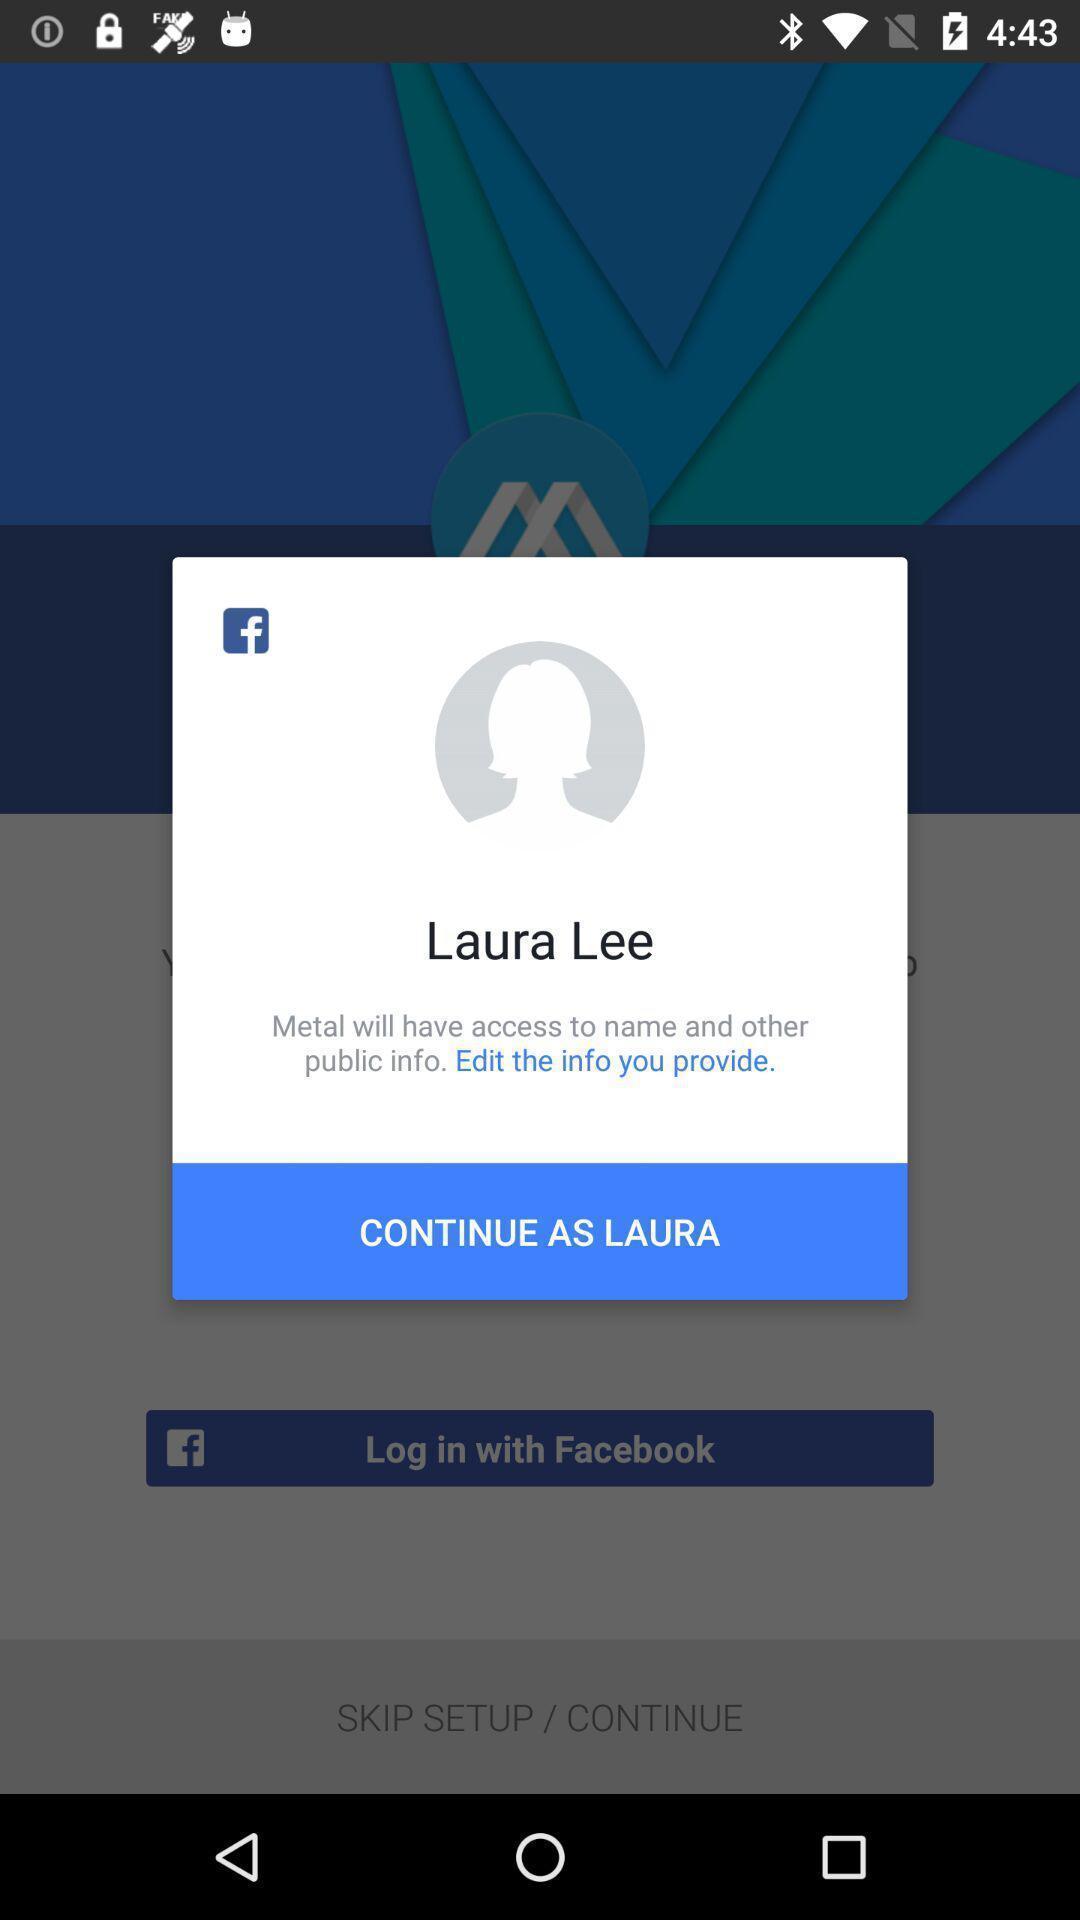What can you discern from this picture? Pop-up shows to continue with a social app. 